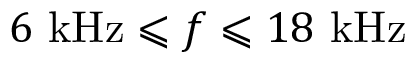<formula> <loc_0><loc_0><loc_500><loc_500>6 k H z \leqslant f \leqslant 1 8 k H z</formula> 